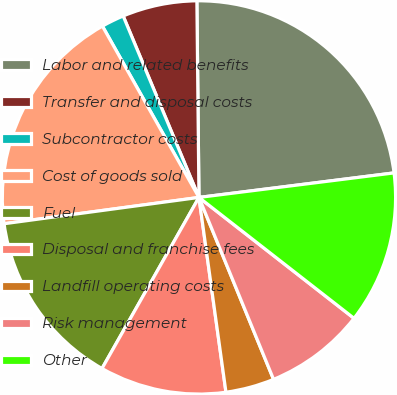Convert chart to OTSL. <chart><loc_0><loc_0><loc_500><loc_500><pie_chart><fcel>Labor and related benefits<fcel>Transfer and disposal costs<fcel>Subcontractor costs<fcel>Cost of goods sold<fcel>Fuel<fcel>Disposal and franchise fees<fcel>Landfill operating costs<fcel>Risk management<fcel>Other<nl><fcel>23.18%<fcel>6.13%<fcel>1.87%<fcel>18.97%<fcel>14.66%<fcel>10.4%<fcel>4.0%<fcel>8.27%<fcel>12.53%<nl></chart> 